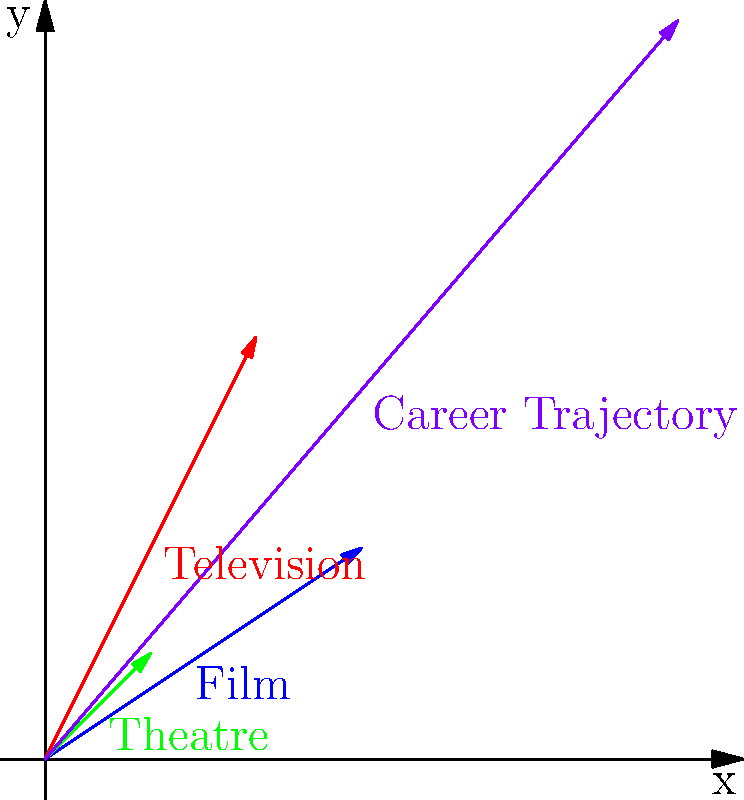In the vector diagram representing Alec Baldwin's career trajectory, which vector represents the sum of his contributions in film, television, and theatre, and what are its coordinates? To find Alec Baldwin's overall career trajectory, we need to add the vectors representing his work in film, television, and theatre:

1. Film vector: $(3, 2)$
2. Television vector: $(2, 4)$
3. Theatre vector: $(1, 1)$

To add these vectors, we sum their x-coordinates and y-coordinates separately:

x-coordinate: $3 + 2 + 1 = 6$
y-coordinate: $2 + 4 + 1 = 7$

Therefore, the vector sum representing Alec Baldwin's career trajectory is $(6, 7)$. This is shown as the purple arrow in the diagram, which starts at the origin $(0, 0)$ and ends at the point $(6, 7)$.
Answer: $(6, 7)$ 